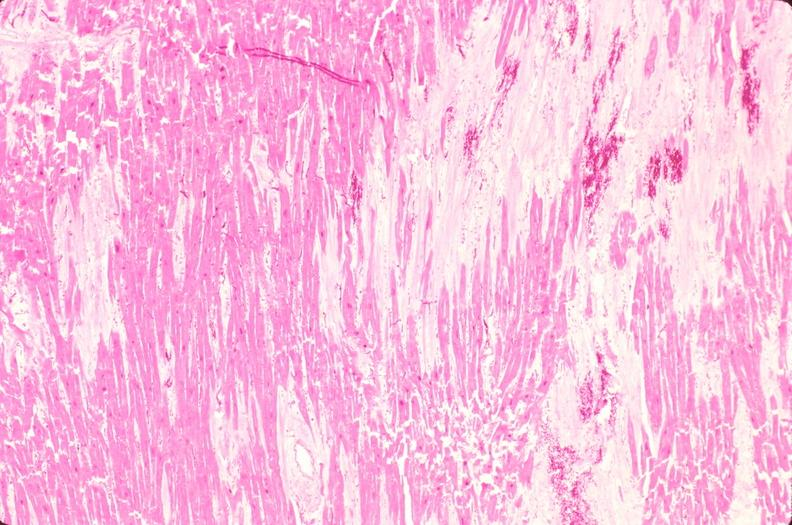what does this image show?
Answer the question using a single word or phrase. Heart 